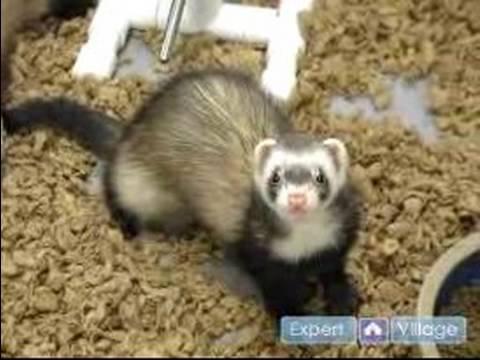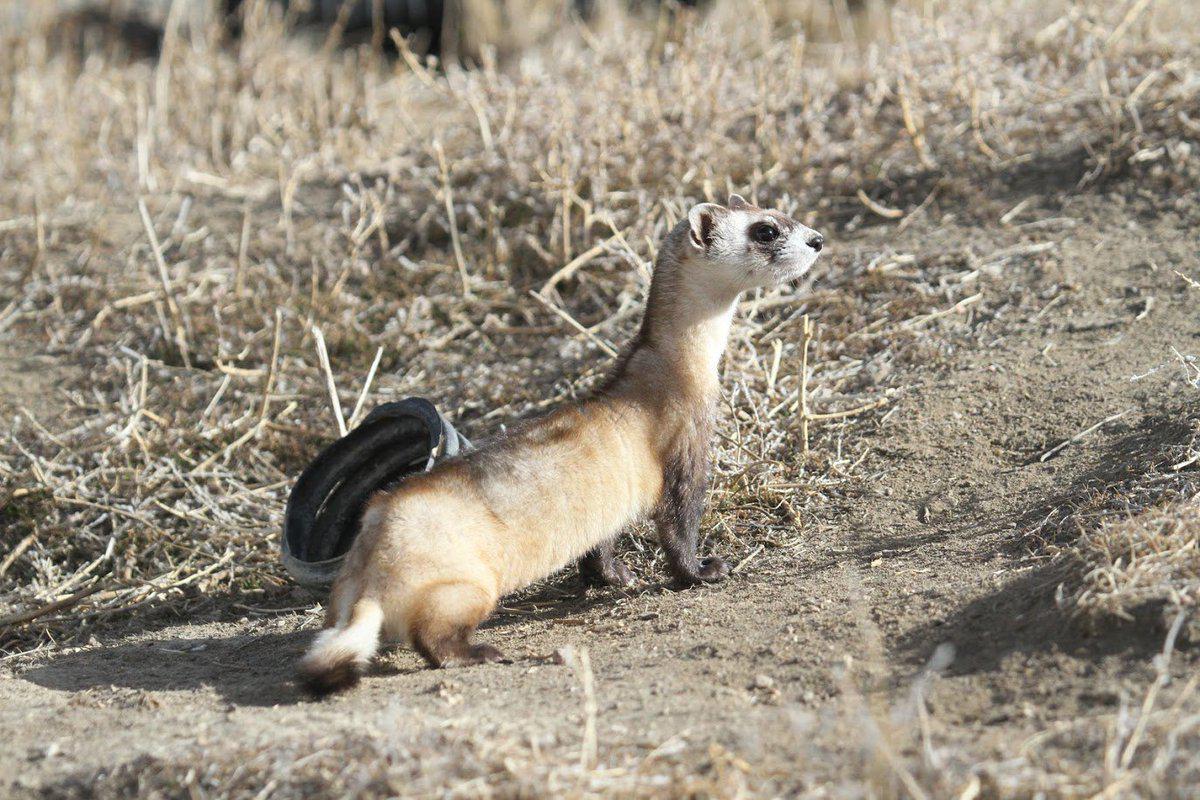The first image is the image on the left, the second image is the image on the right. Evaluate the accuracy of this statement regarding the images: "Each image contains the same number of animals.". Is it true? Answer yes or no. Yes. 